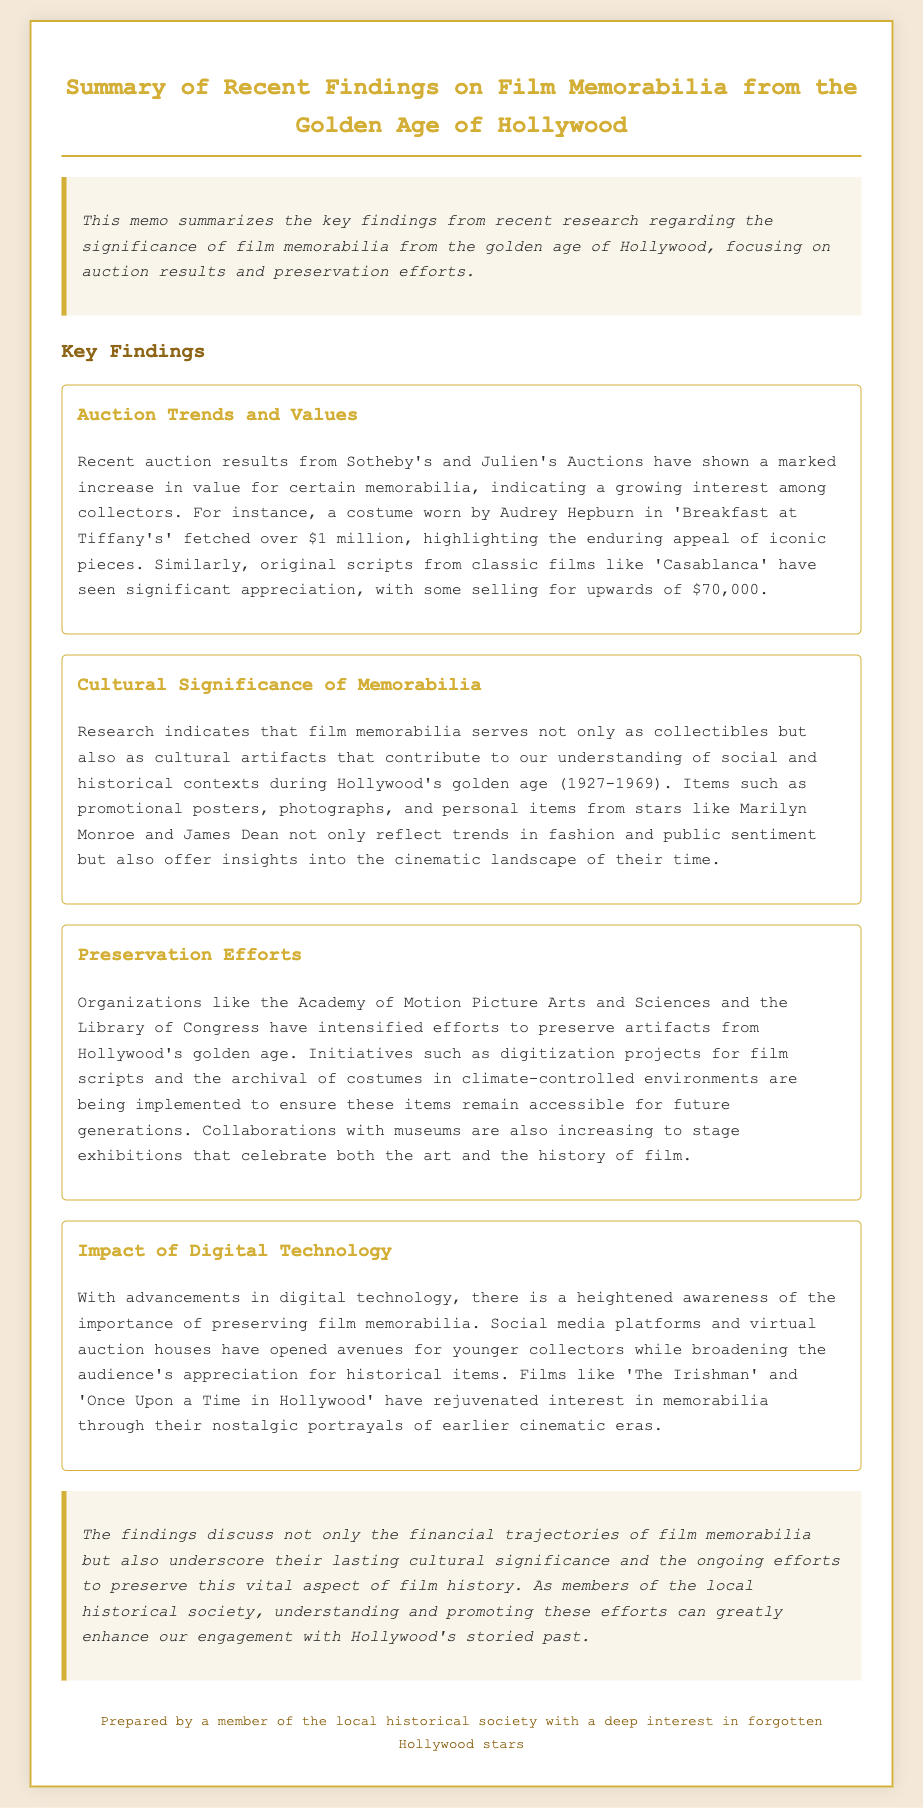What was the auction result for Audrey Hepburn's costume? The document states that a costume worn by Audrey Hepburn in 'Breakfast at Tiffany's' fetched over $1 million.
Answer: over $1 million What is the selling price of original scripts from 'Casablanca'? The document mentions that original scripts from classic films like 'Casablanca' have sold for upwards of $70,000.
Answer: upwards of $70,000 Which organizations are involved in preservation efforts? The document identifies the Academy of Motion Picture Arts and Sciences and the Library of Congress as organizations involved in preservation efforts.
Answer: Academy of Motion Picture Arts and Sciences and the Library of Congress What cultural aspect does film memorabilia represent? The document explains that film memorabilia serves as cultural artifacts that contribute to understanding of social and historical contexts during Hollywood's golden age.
Answer: cultural artifacts How has digital technology impacted awareness of film memorabilia? The document indicates that digital technology has heightened awareness of the importance of preserving film memorabilia.
Answer: heightened awareness What type of items are included in preservation efforts? The document lists film scripts and costumes as types of items included in preservation efforts.
Answer: film scripts and costumes What films are mentioned as rejuvenating interest in memorabilia? The document cites 'The Irishman' and 'Once Upon a Time in Hollywood' as films that have rejuvenated interest in memorabilia.
Answer: The Irishman and Once Upon a Time in Hollywood 